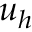<formula> <loc_0><loc_0><loc_500><loc_500>u _ { h }</formula> 